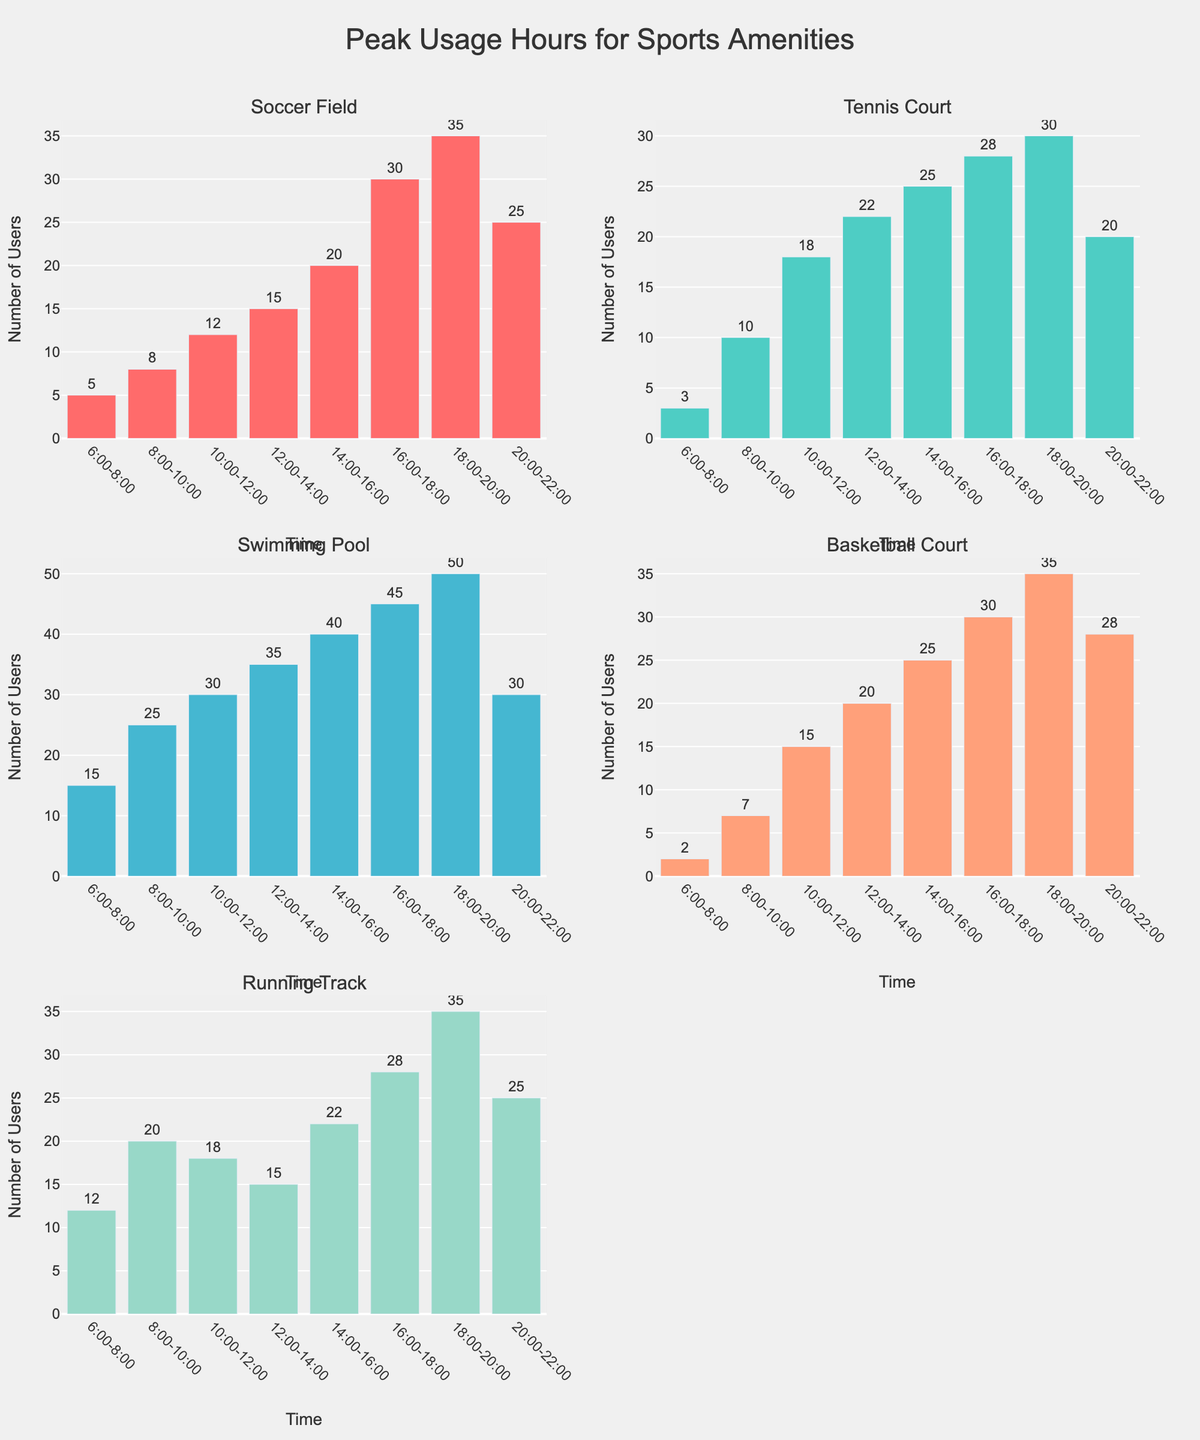What is the title of the figure? The title is displayed prominently at the top center of the figure, stating the overall focus of the chart. It helps viewers quickly grasp the purpose of the chart.
Answer: Peak Usage Hours for Sports Amenities Which sports amenity has the highest peak usage and at what time? Look for the highest bar in the entire figure. Find the associated sport and the time interval at the bottom of the bar.
Answer: Swimming Pool at 18:00-20:00 During which time slot is the running track least used? Find the smallest bar within the Running Track subplot. Identify the time interval at the bottom of this bar.
Answer: 12:00-14:00 Compare the usage of the Soccer Field and Basketball Court at 20:00-22:00. Which one has higher usage? Locate the bars for Soccer Field and Basketball Court within the 20:00-22:00 time interval. Compare their heights to determine which one is higher.
Answer: Basketball Court What's the total usage of the Tennis Court throughout the day? Sum up the height of all bars in the Tennis Court subplot to get the total daily usage. The values are 3+10+18+22+25+28+30+20.
Answer: 156 At what time does the Soccer Field reach its peak usage, and what is its value? Identify the highest bar within the Soccer Field subplot. Read off the time interval and the bar’s height.
Answer: 18:00-20:00, 35 How does the usage of the Swimming Pool at 10:00-12:00 compare to its usage at 20:00-22:00? Locate the bars for the Swimming Pool at 10:00-12:00 and 20:00-22:00. Compare their heights to see which one is higher.
Answer: 30 is greater than 30 What is the average usage for the Running Track throughout the observed time periods? Calculate the average usage by adding up the usage values for each time slot and then dividing by the number of time slots: (12+20+18+15+22+28+35+25)/8.
Answer: 21.875 Which time period has consistent usage spikes across multiple amenities? Look for the time slot where multiple subplots (sports amenities) have relatively high bars.
Answer: 18:00-20:00 What is the difference in usage between the highest peak hours for the Swimming Pool and the Tennis Court? Identify the highest bars in the Swimming Pool and Tennis Court subplots. Subtract the height of the highest Tennis Court bar from the highest Swimming Pool bar.
Answer: 50 - 30 = 20 